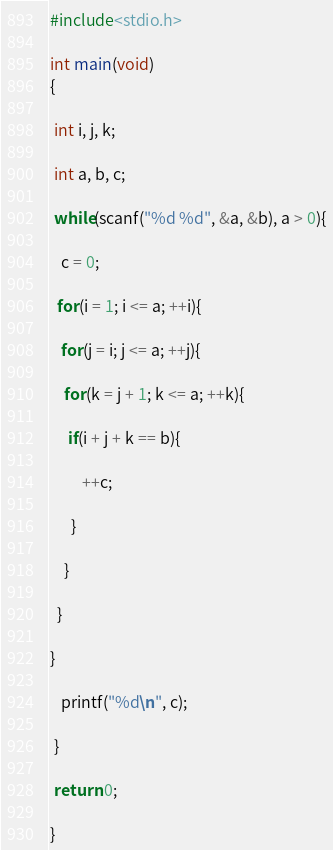<code> <loc_0><loc_0><loc_500><loc_500><_C_>#include<stdio.h>

int main(void)
{

 int i, j, k;

 int a, b, c;

 while(scanf("%d %d", &a, &b), a > 0){

   c = 0;

  for(i = 1; i <= a; ++i){

   for(j = i; j <= a; ++j){

    for(k = j + 1; k <= a; ++k){

     if(i + j + k == b){

         ++c;    

      }

    }

  }

}

   printf("%d\n", c);

 }

 return 0;

}</code> 